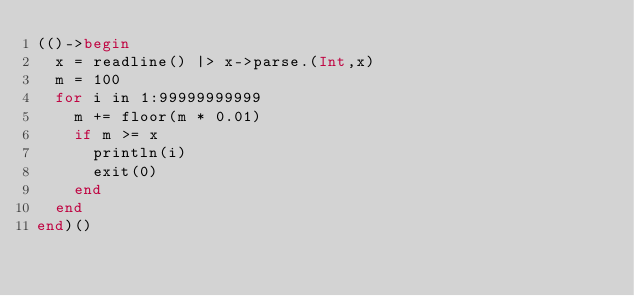<code> <loc_0><loc_0><loc_500><loc_500><_Julia_>(()->begin
  x = readline() |> x->parse.(Int,x)
  m = 100
  for i in 1:99999999999
    m += floor(m * 0.01)
    if m >= x
      println(i)
      exit(0)
    end
  end
end)()
</code> 